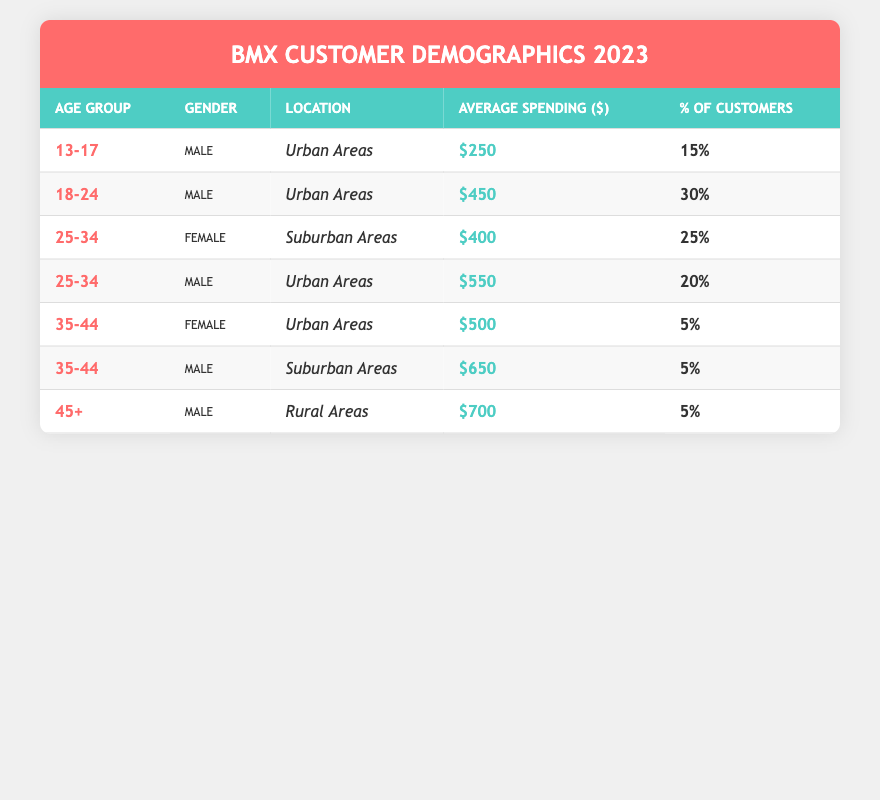What is the average spending of customers in the age group 18-24? The table shows the age group 18-24 has an average spending of $450, which can be found directly in the corresponding row under the "Average Spending" column.
Answer: $450 What percentage of customers in the 25-34 age group are male? According to the table, there are two rows for the 25-34 age group: one for females (25% of customers) and one for males (20% of customers). Thus, the percentage of male customers in that age group is 20%.
Answer: 20% Is there any customer from the 45+ age group located in urban areas? Looking through the table, the entry for the age group of 45+ indicates the customer is located in rural areas. Therefore, there are no customers in the 45+ age group residing in urban areas.
Answer: No How much does the average spending differ between male and female customers in the age group 35-44? In the table, the average spending for female customers in the 35-44 age group is $500, whereas for male customers it is $650. The difference between them is $650 - $500 = $150.
Answer: $150 What age group has the highest average spending? By reviewing the table, the highest average spending is $700 from the 45+ age group male customers. This is the maximum value listed under the "Average Spending" column.
Answer: 45+ How many customers from urban areas contributed to the total? The data shows that there are three entries for customers in urban areas: 15% (age 13-17), 30% (age 18-24), and 20% (age 25-34 male), plus 5% (age 35-44 female). Adding these percentages gives us: 15% + 30% + 20% + 5% = 70%.
Answer: 70% Which gender has a higher average spending in the age group 25-34? In the 25-34 age group, the average spending for females is listed as $400, while for males it is $550. Therefore, males have the higher average spending in this age group.
Answer: Male What is the total percentage of customers aged 35 and older? There are two age groups meeting this criterion: 35-44 (5% female and 5% male) and 45+ (5% male). Adding these gives us a total of 5% + 5% + 5% = 15% for customers aged 35 and older.
Answer: 15% 